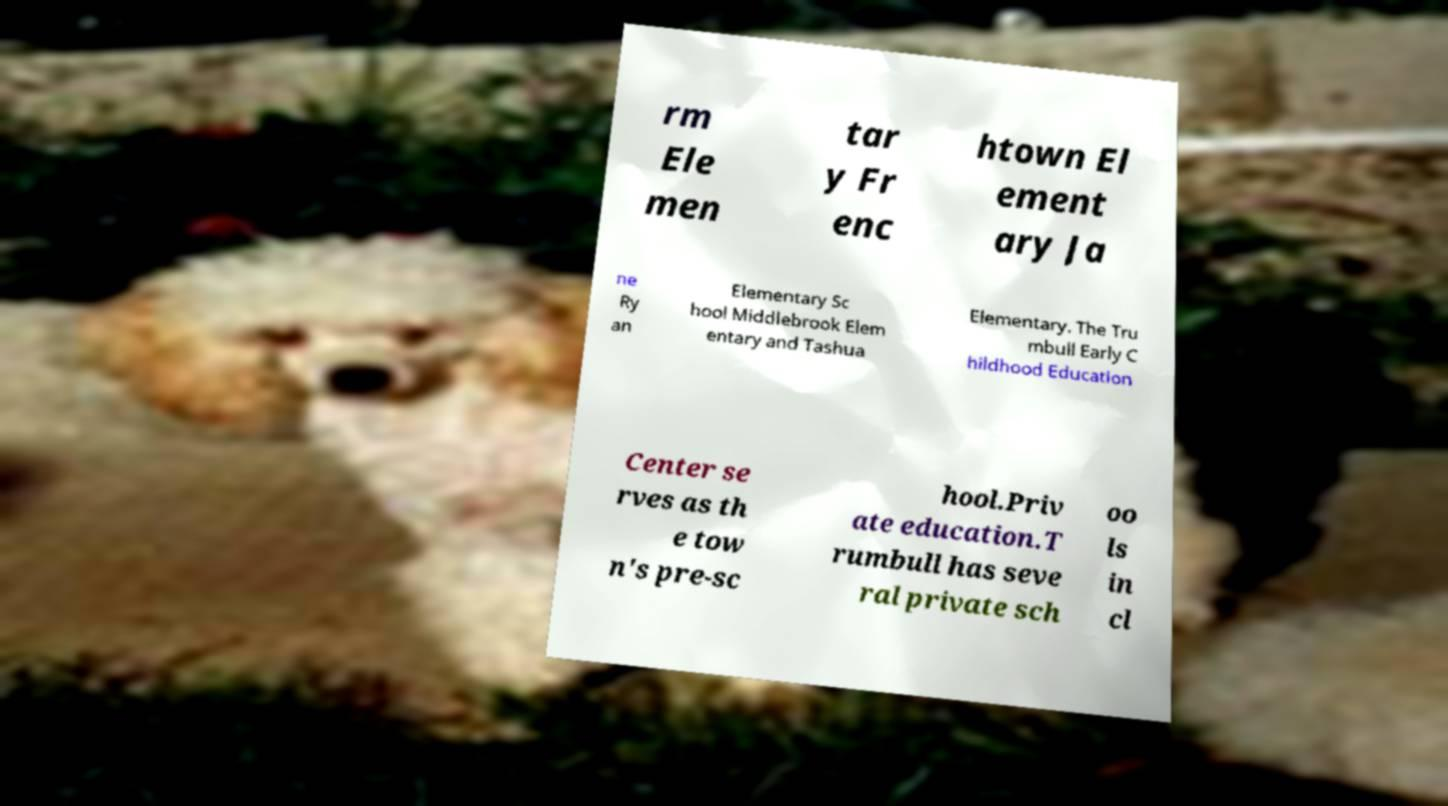Can you read and provide the text displayed in the image?This photo seems to have some interesting text. Can you extract and type it out for me? rm Ele men tar y Fr enc htown El ement ary Ja ne Ry an Elementary Sc hool Middlebrook Elem entary and Tashua Elementary. The Tru mbull Early C hildhood Education Center se rves as th e tow n's pre-sc hool.Priv ate education.T rumbull has seve ral private sch oo ls in cl 